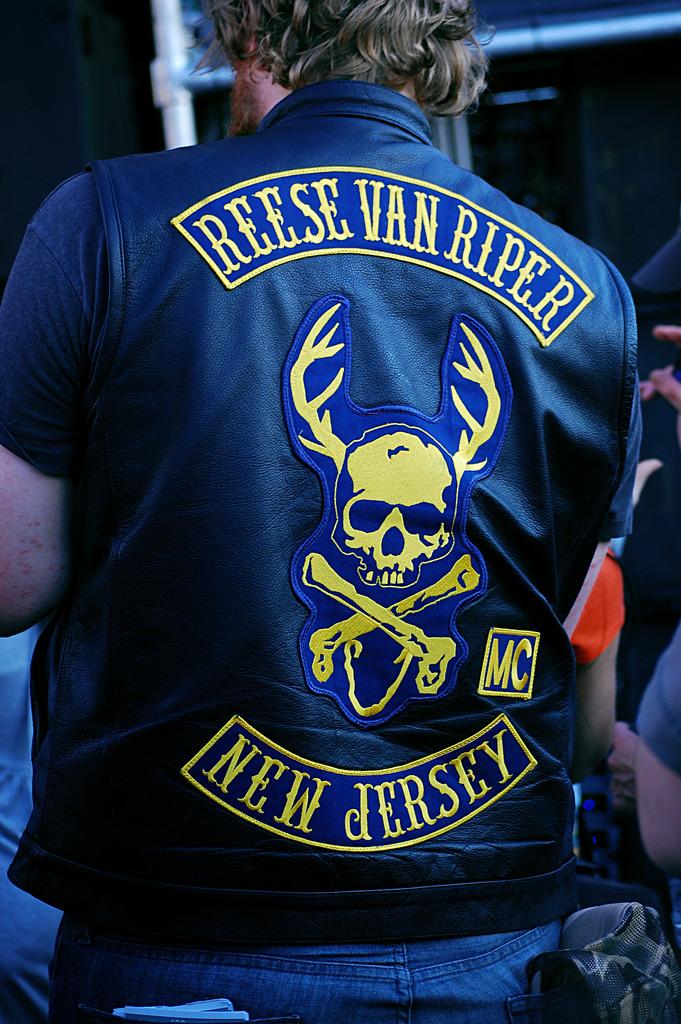What state is reese van ripen in?
Offer a terse response. New jersey. Who is this shirt embroidered for?
Your answer should be very brief. Reese van riper. 